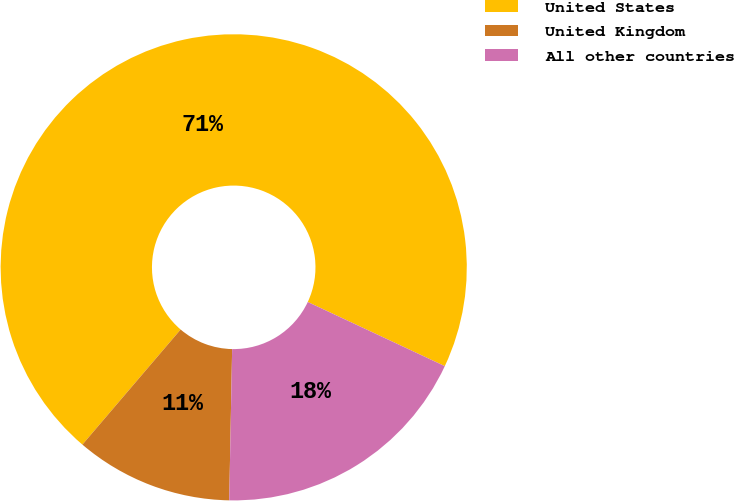Convert chart to OTSL. <chart><loc_0><loc_0><loc_500><loc_500><pie_chart><fcel>United States<fcel>United Kingdom<fcel>All other countries<nl><fcel>70.73%<fcel>10.94%<fcel>18.34%<nl></chart> 